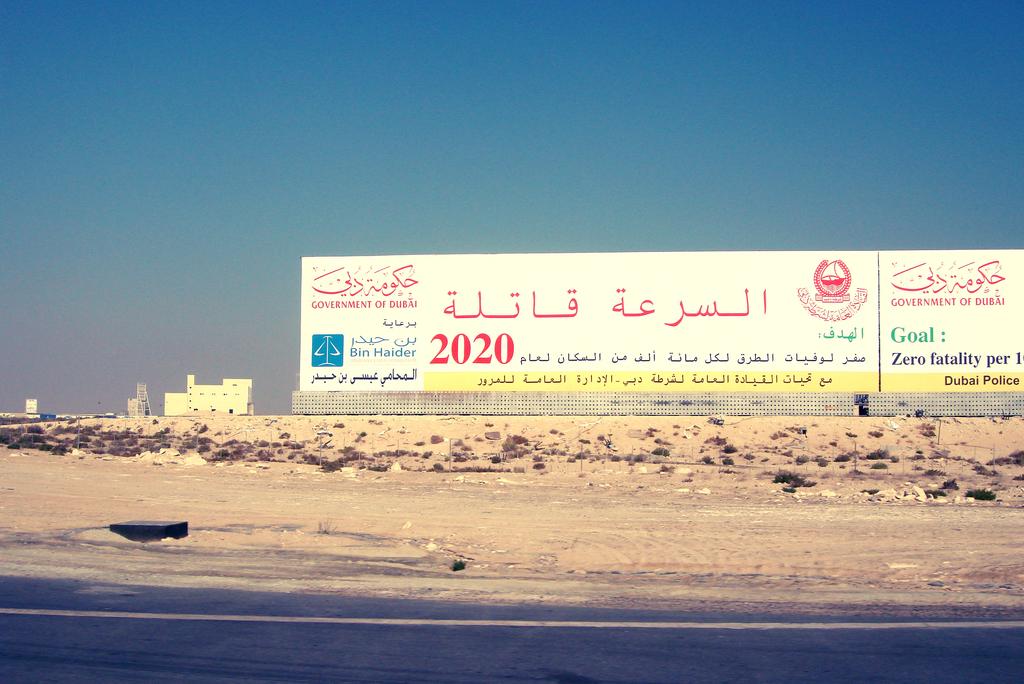What is the goal of these advertisements?
Make the answer very short. Zero fatality. What year is written in read?
Give a very brief answer. 2020. 